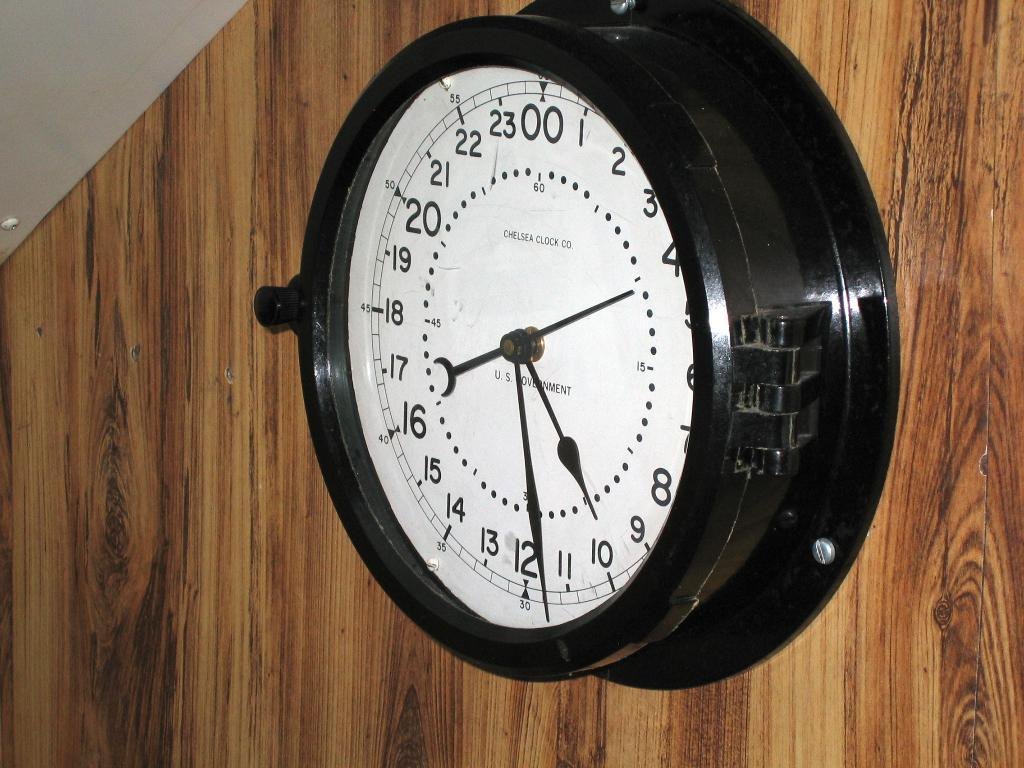What type of wall is present in the image? There is a wooden wall in the image. How is the wooden wall depicted? The wooden wall is truncated in the image. What can be seen on the wooden wall? There is a wall clock on the wooden wall. What part of the building is visible in the image? The roof is visible in the image. How is the roof depicted? The roof is truncated towards the top of the image. What object is present on the roof? There is an object on the roof. What type of thrill can be seen on the roof in the image? There is no thrill present on the roof in the image. What color is the feather on the wooden wall in the image? There is no feather present on the wooden wall in the image. 